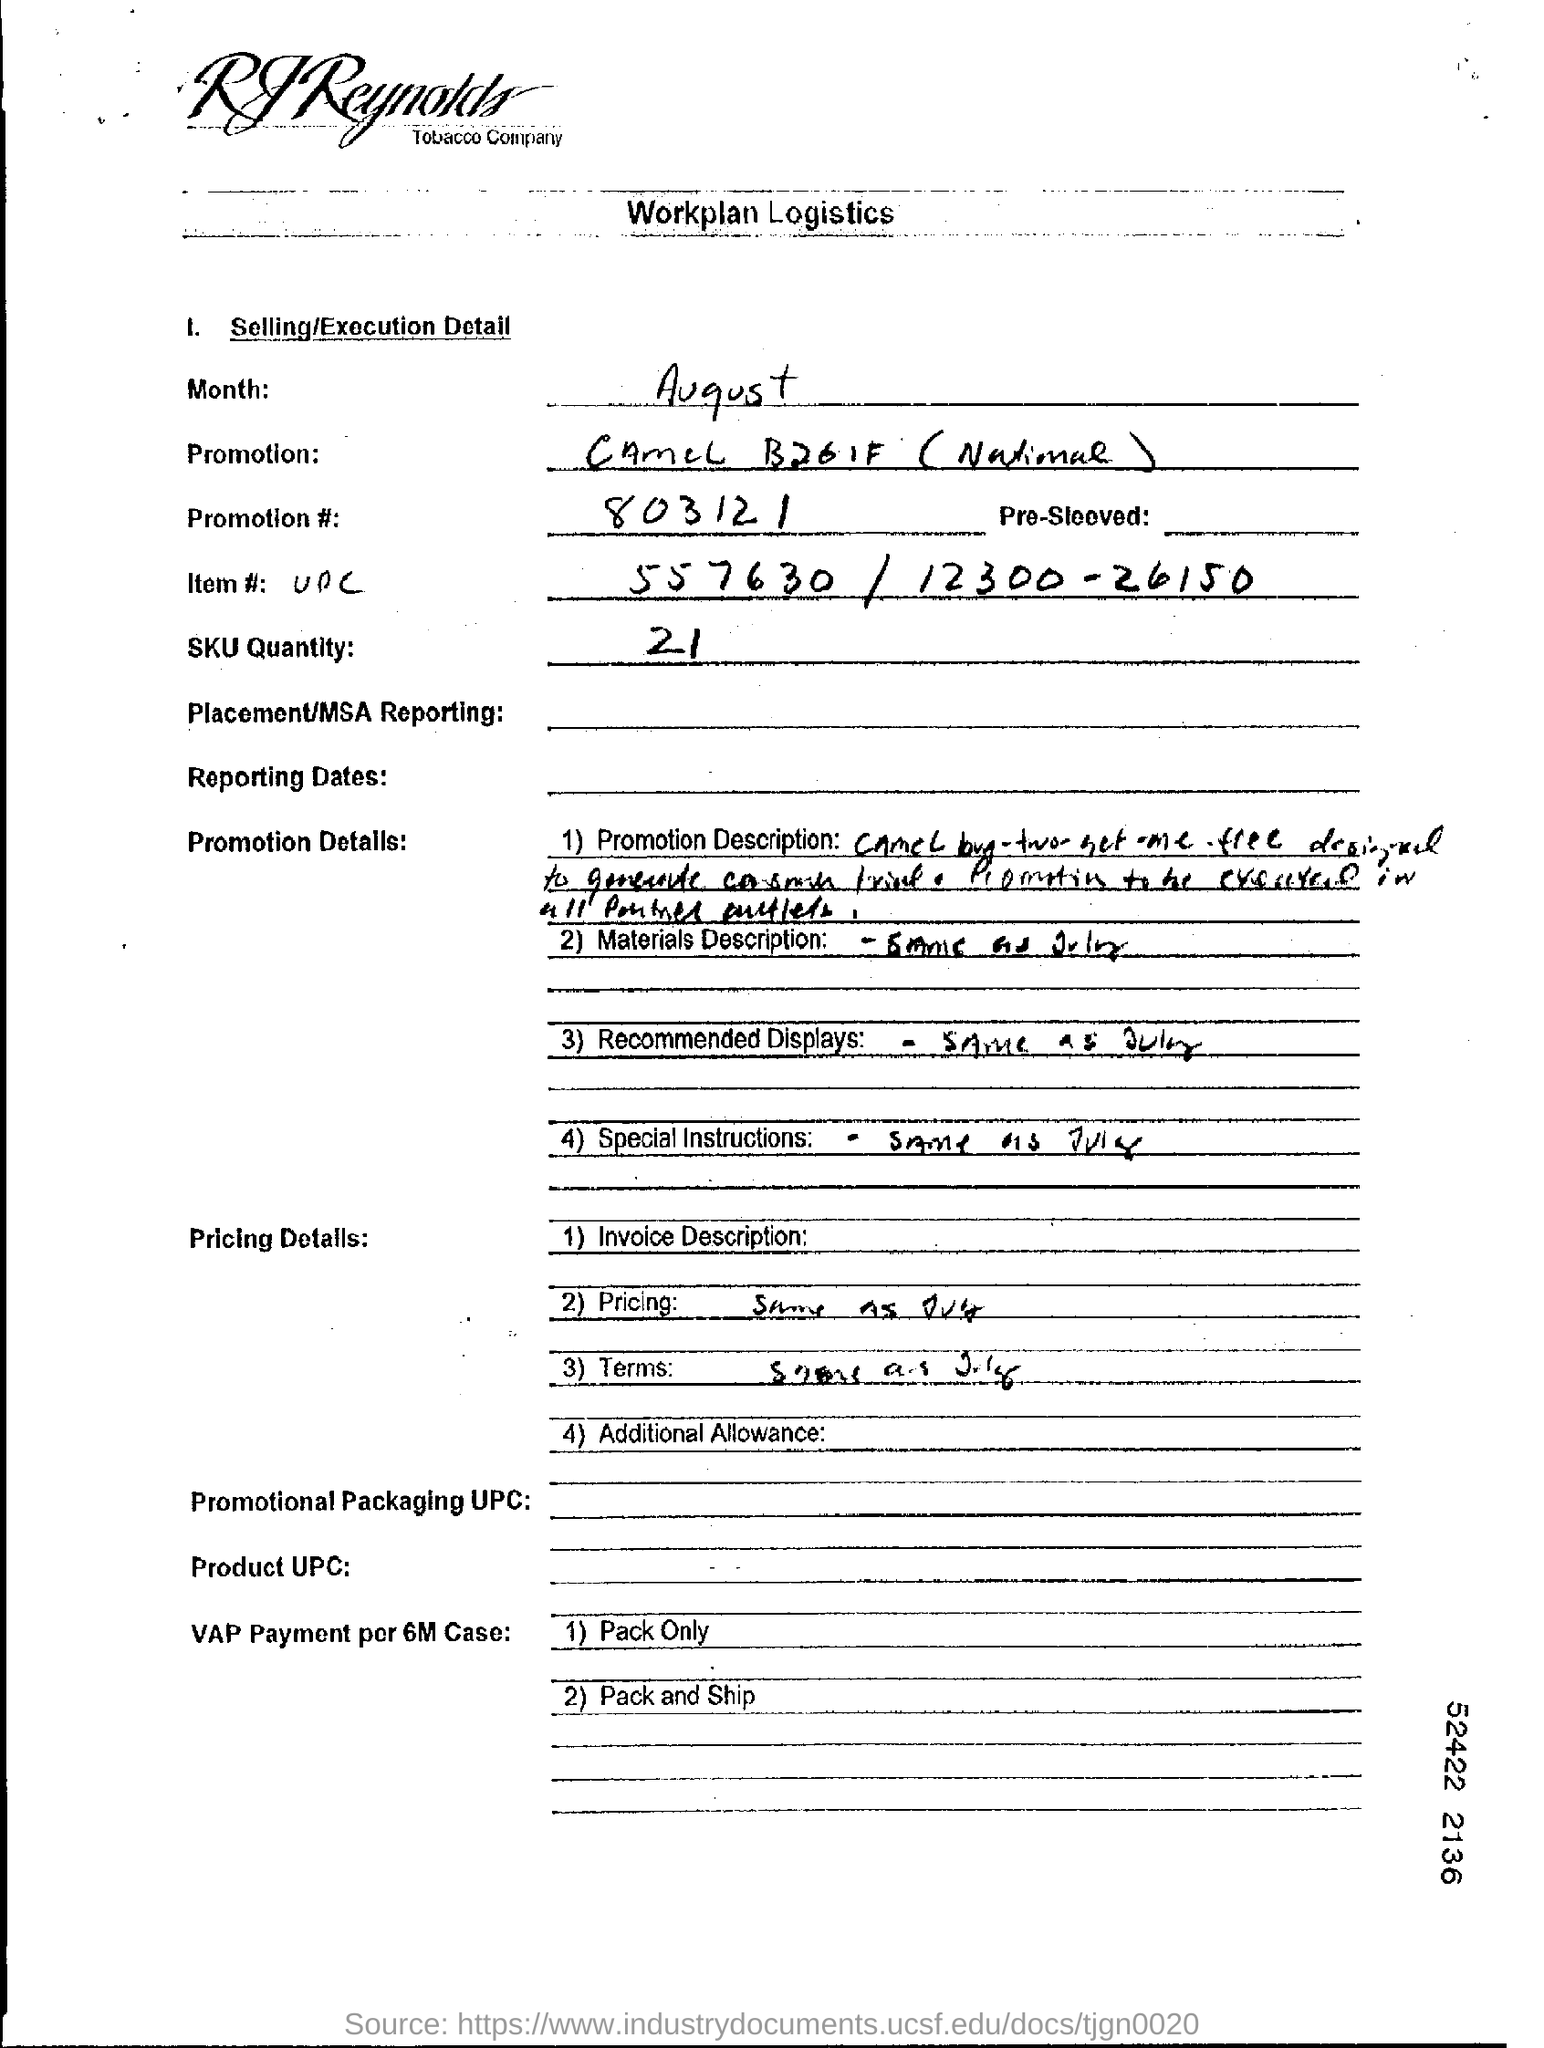Outline some significant characteristics in this image. The SKU quantity is 21. What is the promotion number? It is 803121... 